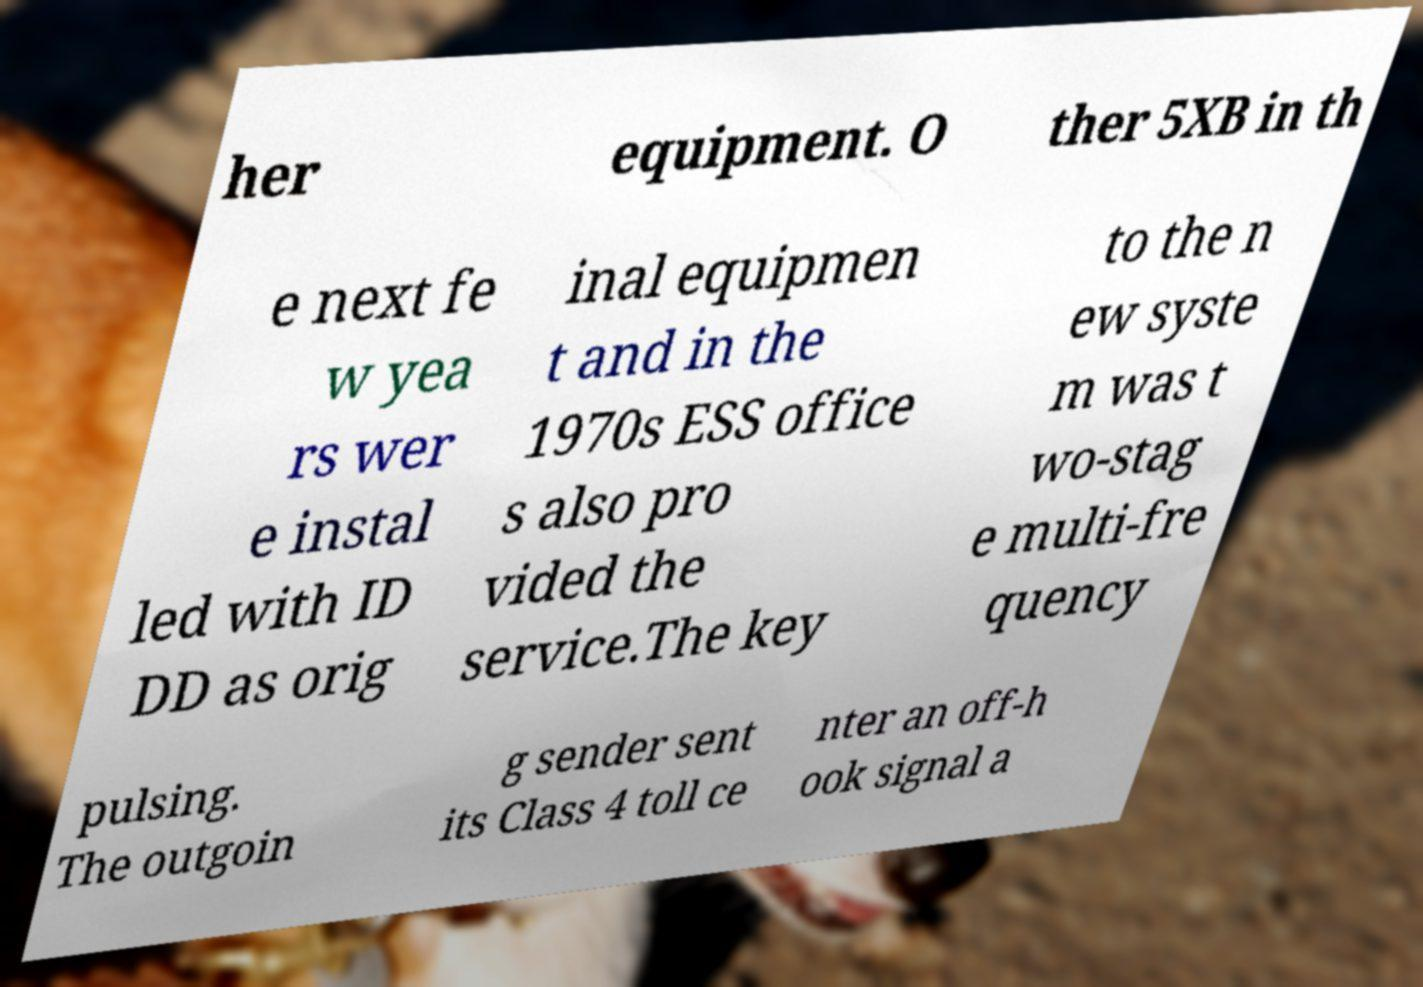Could you extract and type out the text from this image? her equipment. O ther 5XB in th e next fe w yea rs wer e instal led with ID DD as orig inal equipmen t and in the 1970s ESS office s also pro vided the service.The key to the n ew syste m was t wo-stag e multi-fre quency pulsing. The outgoin g sender sent its Class 4 toll ce nter an off-h ook signal a 